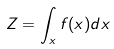Convert formula to latex. <formula><loc_0><loc_0><loc_500><loc_500>Z = \int _ { x } f ( x ) d x</formula> 